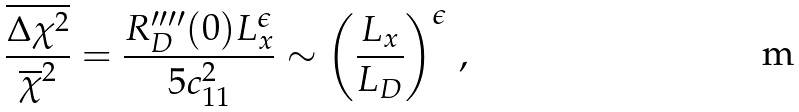<formula> <loc_0><loc_0><loc_500><loc_500>\frac { \overline { \Delta \chi ^ { 2 } } } { \overline { \chi } ^ { 2 } } = \frac { R _ { D } ^ { \prime \prime \prime \prime } ( 0 ) L _ { x } ^ { \epsilon } } { 5 c _ { 1 1 } ^ { 2 } } \sim \left ( \frac { L _ { x } } { L _ { D } } \right ) ^ { \epsilon } \, ,</formula> 